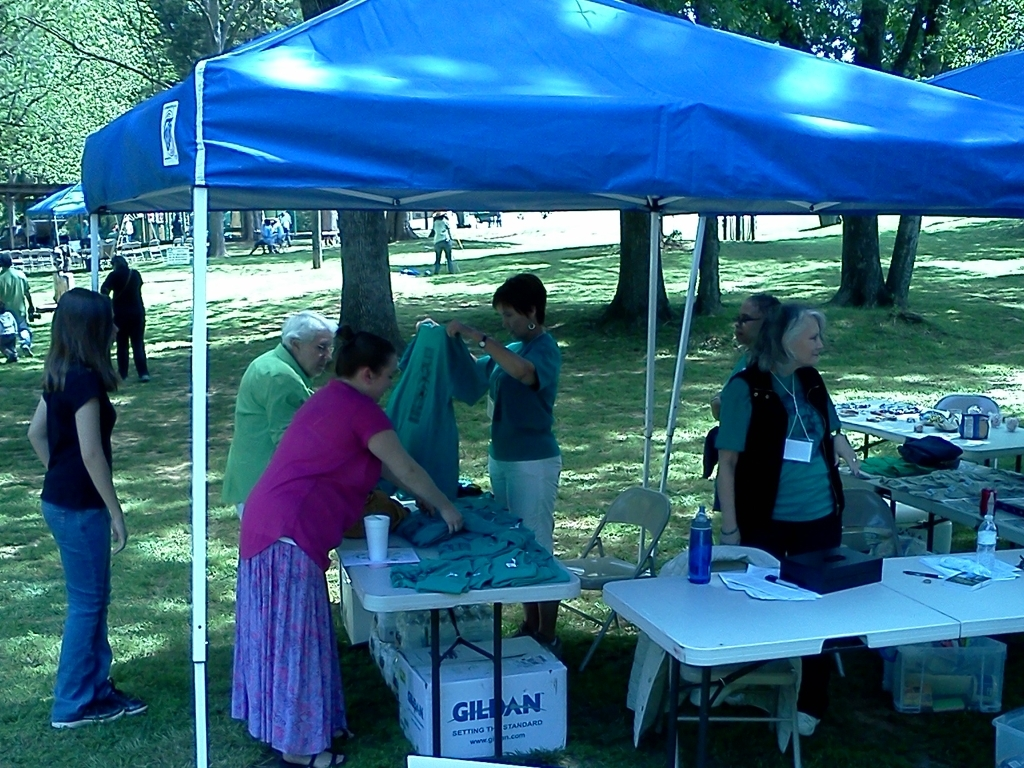What kind of location does this event seem to be at? The event is set in an outdoor park setting, characterized by green grass and trees in the background. The open space and casual attire of attendees suggest a relaxed and informal event meant for community engagement in a public area that's easily accessible to everyone. How does the environment contribute to the atmosphere of the event? The outdoor environment contributes greatly to the atmosphere, providing a welcoming and airy space for people to mingle and participate. The natural light and fresh air can make the event feel more inviting, encouraging participants to stay longer and enjoy the activities. Additionally, the park setting is conducive to family-friendly events, which might be why we see a range of age groups present. 